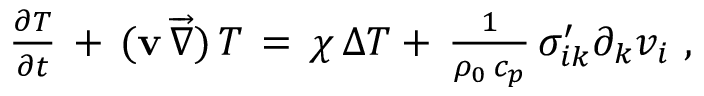<formula> <loc_0><loc_0><loc_500><loc_500>\begin{array} { r } { \frac { \partial { T } } { \partial t } \, + \, ( { v } \, \overrightarrow { \nabla } ) \, { T } \, = \, \chi \, \Delta T + \, \frac { 1 } { \rho _ { 0 } \, c _ { p } } \, \sigma _ { i k } ^ { \prime } \partial _ { k } v _ { i } \ , \ \ } \end{array}</formula> 